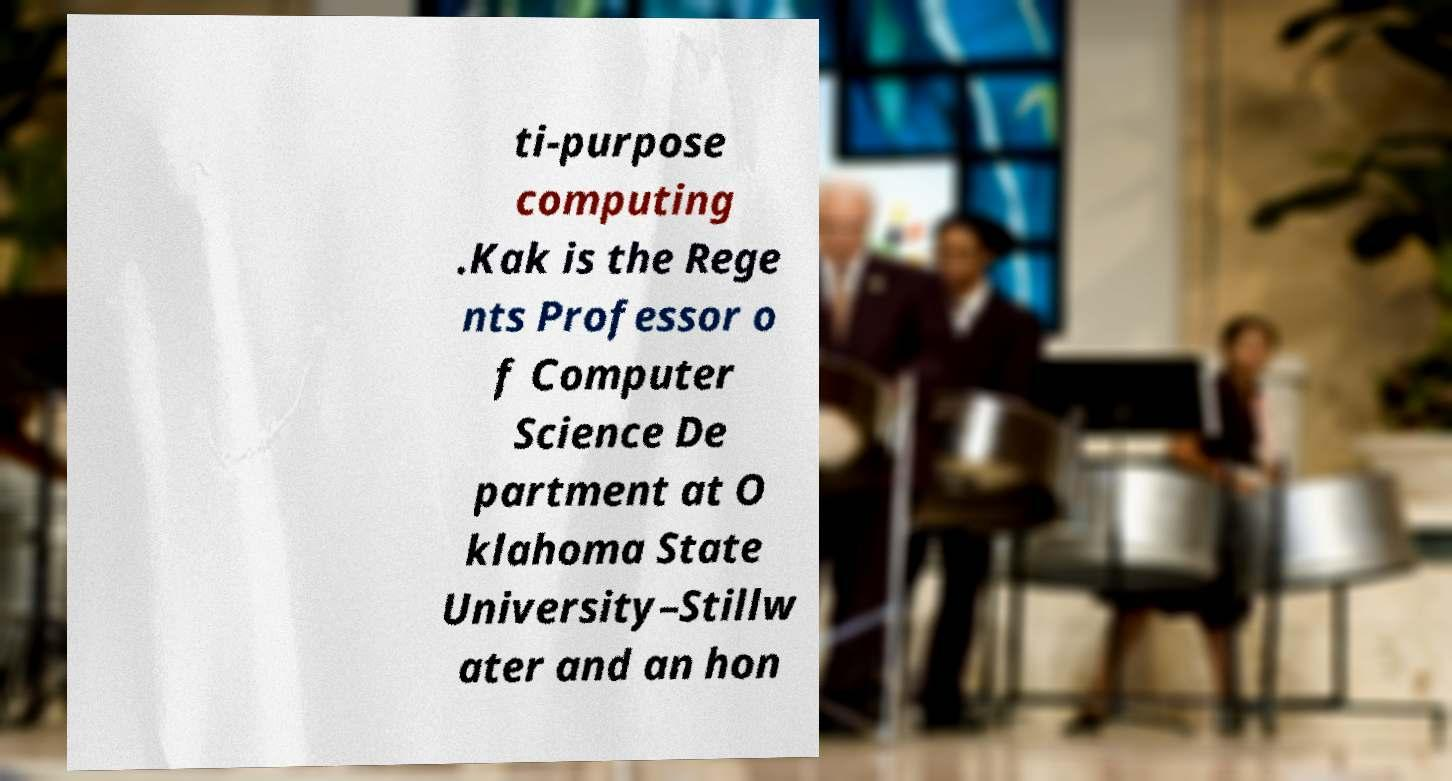Please read and relay the text visible in this image. What does it say? ti-purpose computing .Kak is the Rege nts Professor o f Computer Science De partment at O klahoma State University–Stillw ater and an hon 